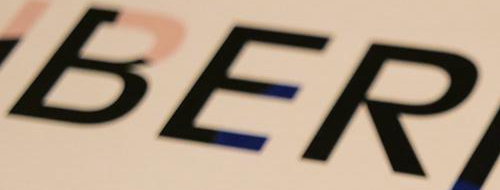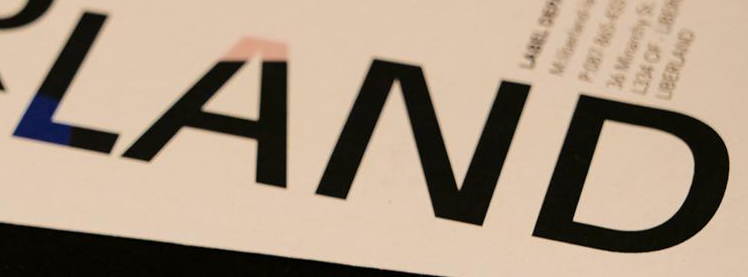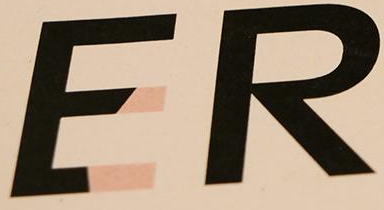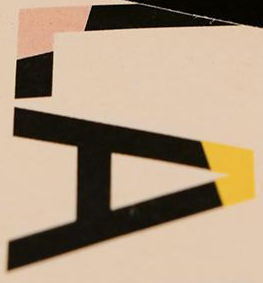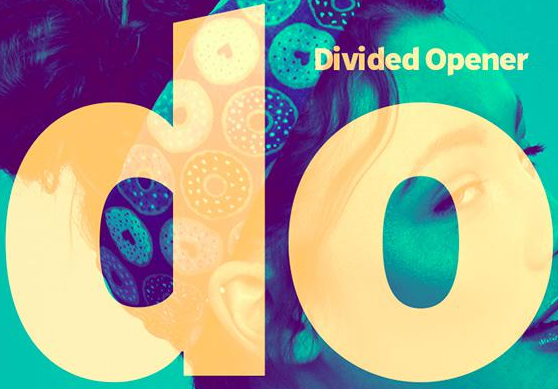Identify the words shown in these images in order, separated by a semicolon. BER; LAND; ER; LA; do 